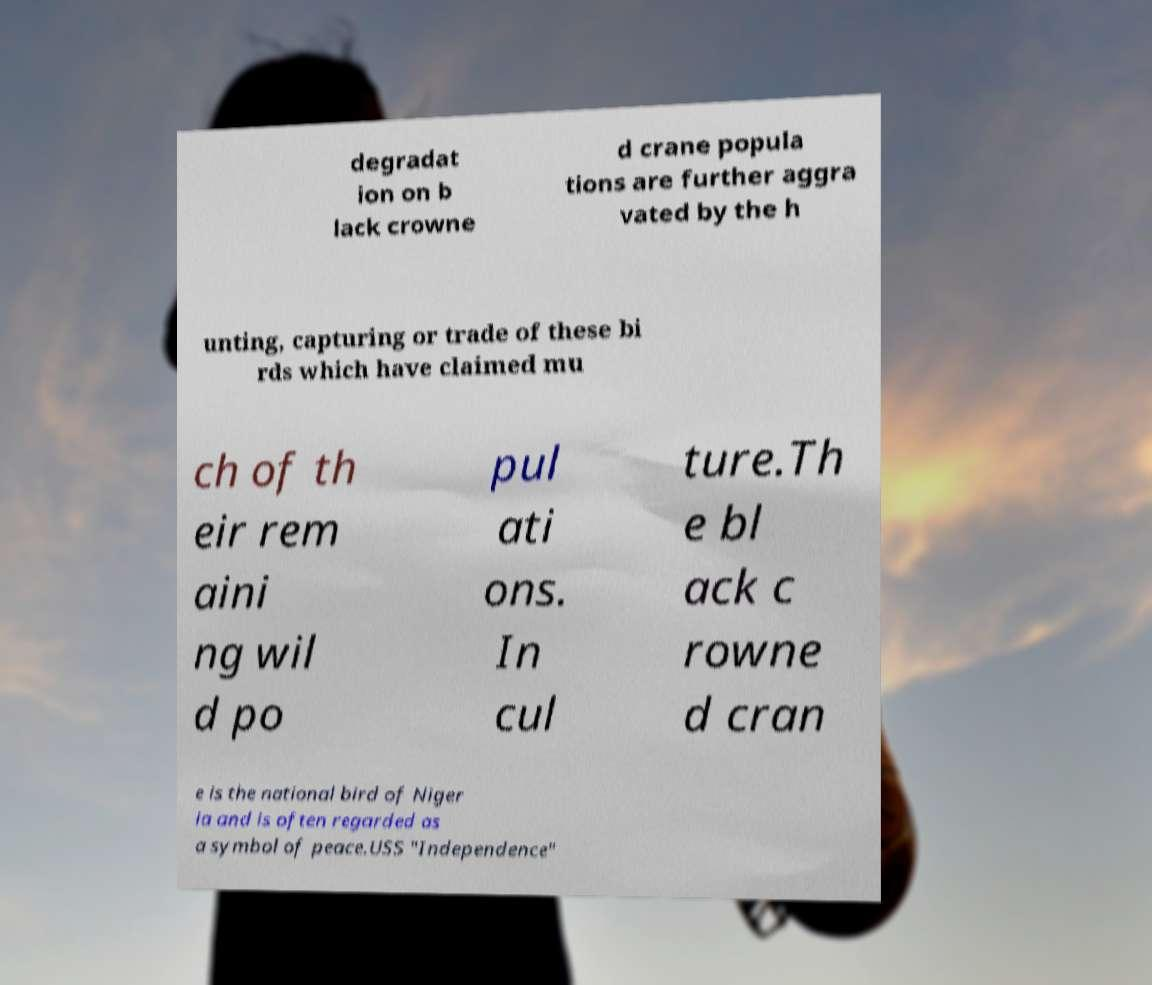Can you accurately transcribe the text from the provided image for me? degradat ion on b lack crowne d crane popula tions are further aggra vated by the h unting, capturing or trade of these bi rds which have claimed mu ch of th eir rem aini ng wil d po pul ati ons. In cul ture.Th e bl ack c rowne d cran e is the national bird of Niger ia and is often regarded as a symbol of peace.USS "Independence" 